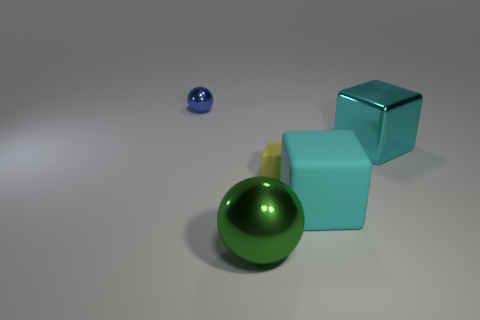Subtract all purple blocks. Subtract all purple spheres. How many blocks are left? 3 Add 2 matte objects. How many objects exist? 7 Subtract all cubes. How many objects are left? 2 Add 4 small cubes. How many small cubes are left? 5 Add 5 green objects. How many green objects exist? 6 Subtract 1 blue spheres. How many objects are left? 4 Subtract all red rubber spheres. Subtract all large objects. How many objects are left? 2 